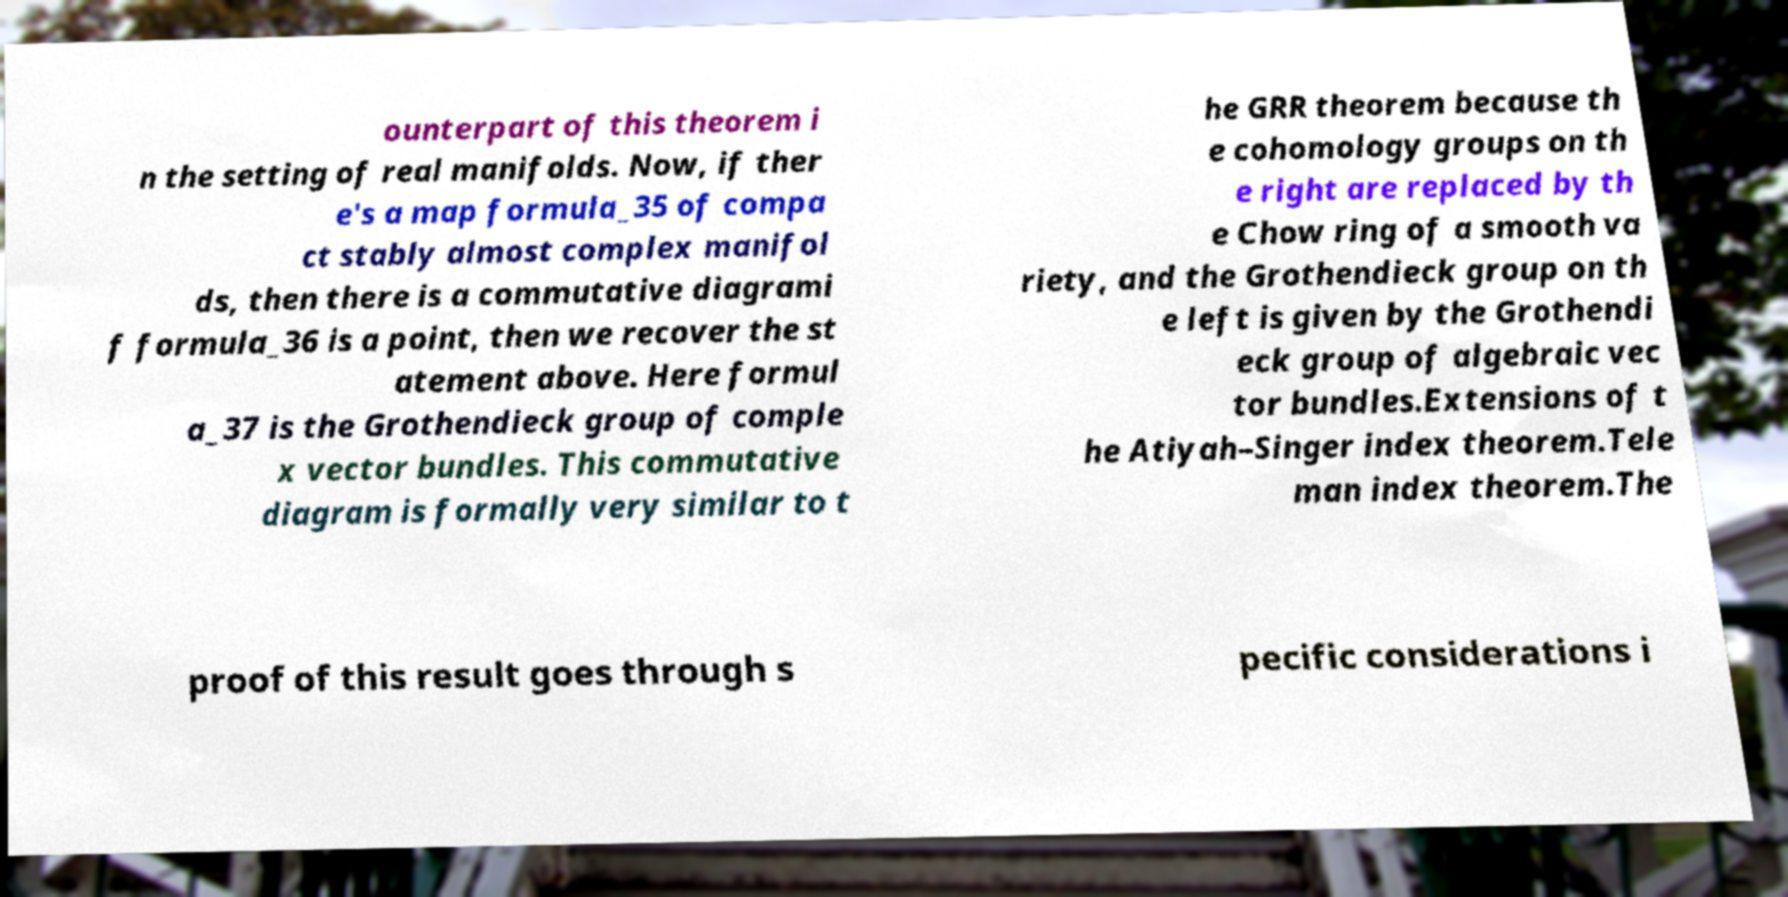What messages or text are displayed in this image? I need them in a readable, typed format. ounterpart of this theorem i n the setting of real manifolds. Now, if ther e's a map formula_35 of compa ct stably almost complex manifol ds, then there is a commutative diagrami f formula_36 is a point, then we recover the st atement above. Here formul a_37 is the Grothendieck group of comple x vector bundles. This commutative diagram is formally very similar to t he GRR theorem because th e cohomology groups on th e right are replaced by th e Chow ring of a smooth va riety, and the Grothendieck group on th e left is given by the Grothendi eck group of algebraic vec tor bundles.Extensions of t he Atiyah–Singer index theorem.Tele man index theorem.The proof of this result goes through s pecific considerations i 